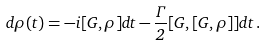Convert formula to latex. <formula><loc_0><loc_0><loc_500><loc_500>d \rho ( t ) = - i [ G , \rho ] d t - \frac { \Gamma } { 2 } [ G , [ G , \rho ] ] d t \, .</formula> 